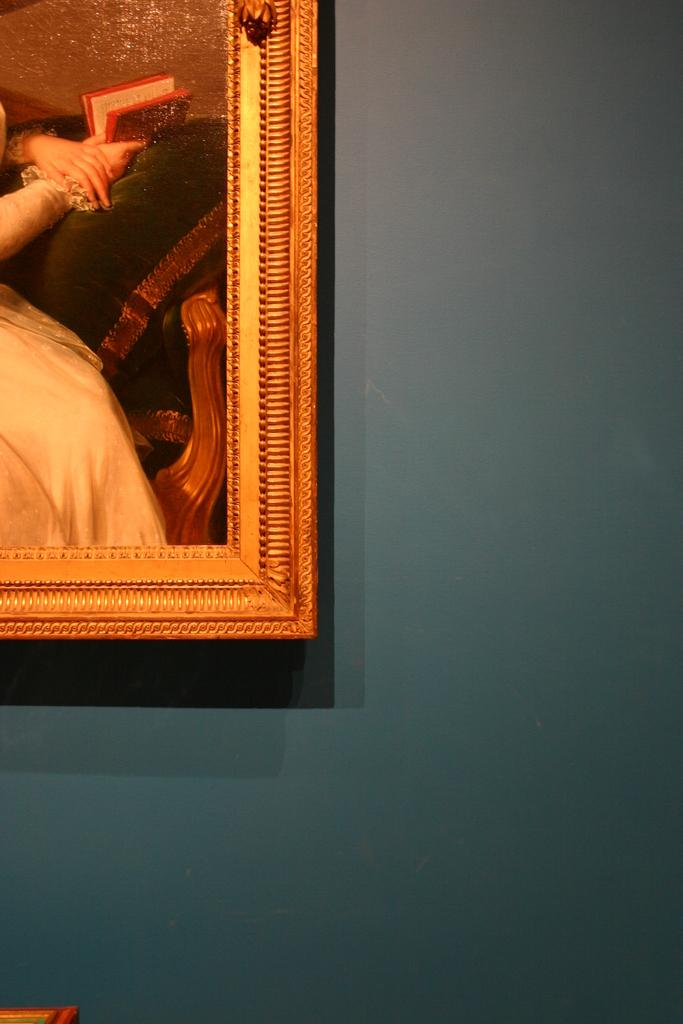What is the main object in the image? There is a frame in the image. Where is the frame located? The frame is attached to a blue wall. What is the tendency of the pail to hold water in the image? There is no pail present in the image, so it is not possible to determine its tendency to hold water. 